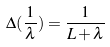Convert formula to latex. <formula><loc_0><loc_0><loc_500><loc_500>\Delta ( \frac { 1 } { \lambda } ) = \frac { 1 } { L + \lambda }</formula> 